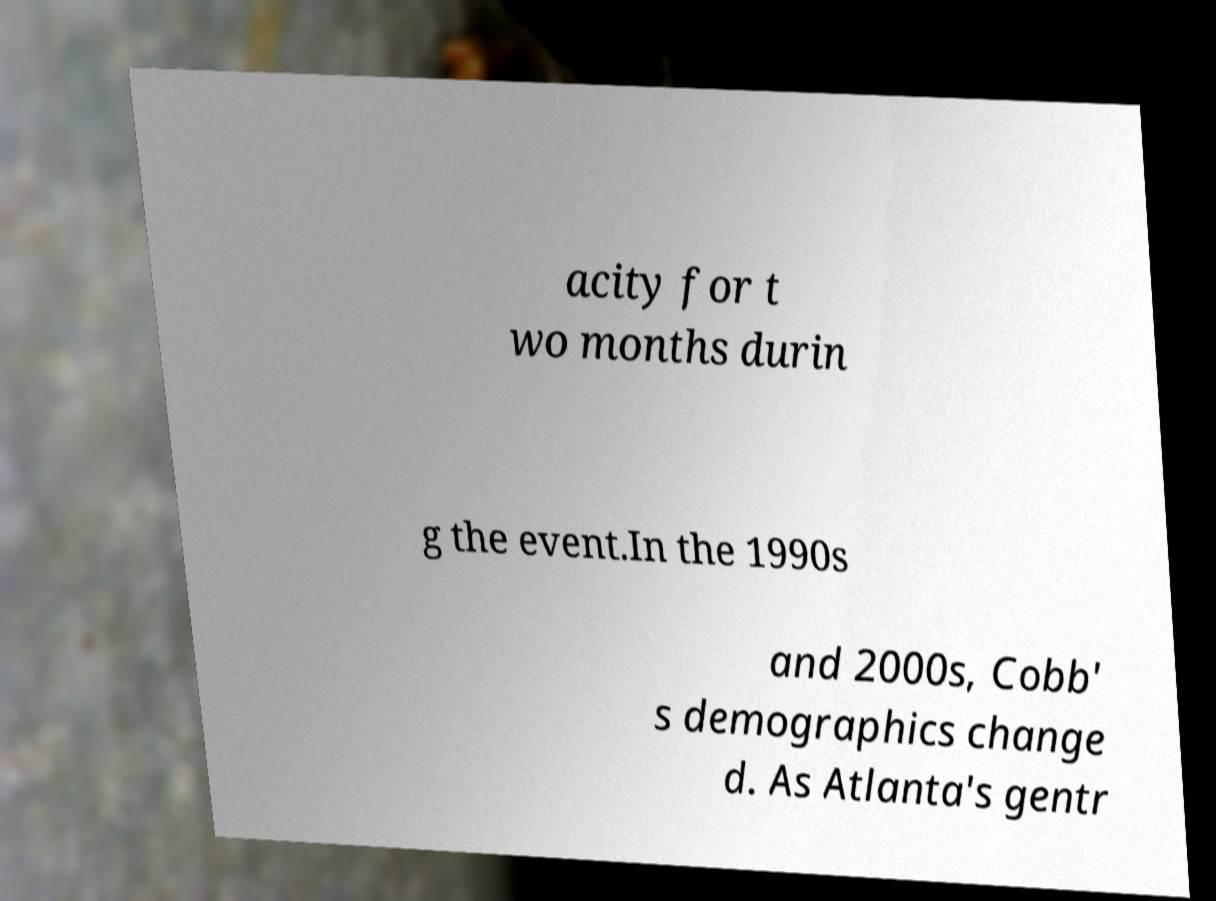Please read and relay the text visible in this image. What does it say? acity for t wo months durin g the event.In the 1990s and 2000s, Cobb' s demographics change d. As Atlanta's gentr 